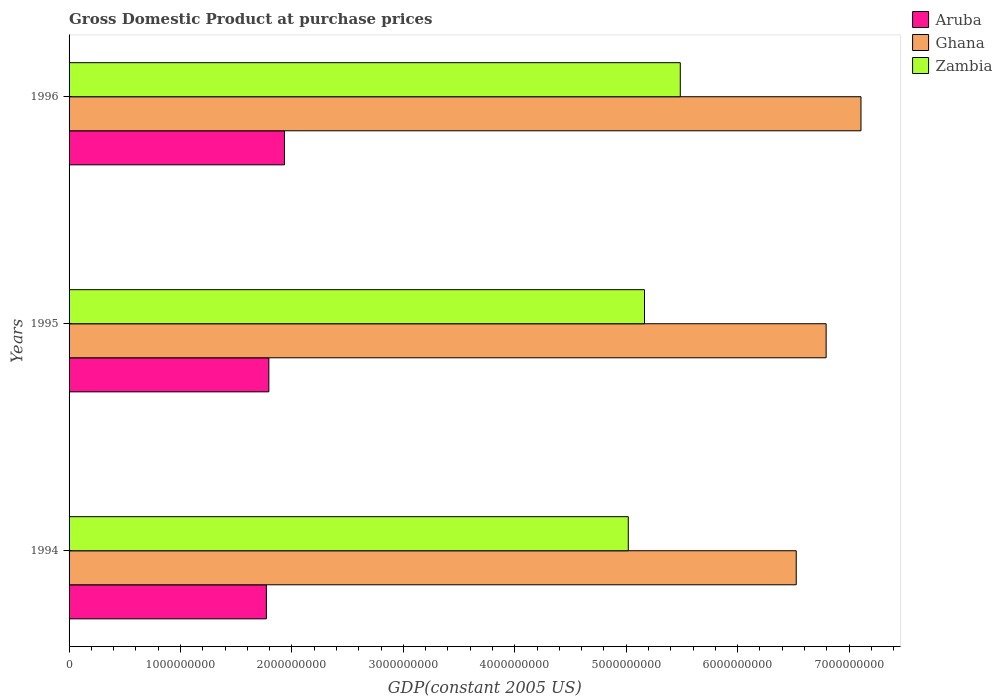How many different coloured bars are there?
Ensure brevity in your answer.  3. How many groups of bars are there?
Offer a terse response. 3. Are the number of bars per tick equal to the number of legend labels?
Your answer should be very brief. Yes. How many bars are there on the 2nd tick from the bottom?
Provide a short and direct response. 3. What is the label of the 3rd group of bars from the top?
Your response must be concise. 1994. In how many cases, is the number of bars for a given year not equal to the number of legend labels?
Your answer should be compact. 0. What is the GDP at purchase prices in Ghana in 1994?
Your response must be concise. 6.53e+09. Across all years, what is the maximum GDP at purchase prices in Ghana?
Offer a very short reply. 7.11e+09. Across all years, what is the minimum GDP at purchase prices in Zambia?
Offer a terse response. 5.02e+09. In which year was the GDP at purchase prices in Ghana minimum?
Your answer should be compact. 1994. What is the total GDP at purchase prices in Aruba in the graph?
Your answer should be very brief. 5.50e+09. What is the difference between the GDP at purchase prices in Aruba in 1994 and that in 1995?
Your answer should be very brief. -2.20e+07. What is the difference between the GDP at purchase prices in Aruba in 1994 and the GDP at purchase prices in Ghana in 1996?
Make the answer very short. -5.34e+09. What is the average GDP at purchase prices in Zambia per year?
Your answer should be very brief. 5.22e+09. In the year 1995, what is the difference between the GDP at purchase prices in Aruba and GDP at purchase prices in Ghana?
Your answer should be very brief. -5.00e+09. What is the ratio of the GDP at purchase prices in Aruba in 1994 to that in 1996?
Provide a succinct answer. 0.92. Is the GDP at purchase prices in Aruba in 1994 less than that in 1995?
Offer a very short reply. Yes. Is the difference between the GDP at purchase prices in Aruba in 1994 and 1995 greater than the difference between the GDP at purchase prices in Ghana in 1994 and 1995?
Your answer should be very brief. Yes. What is the difference between the highest and the second highest GDP at purchase prices in Zambia?
Provide a succinct answer. 3.21e+08. What is the difference between the highest and the lowest GDP at purchase prices in Zambia?
Your answer should be compact. 4.67e+08. In how many years, is the GDP at purchase prices in Aruba greater than the average GDP at purchase prices in Aruba taken over all years?
Your answer should be compact. 1. What does the 1st bar from the top in 1996 represents?
Make the answer very short. Zambia. What does the 3rd bar from the bottom in 1994 represents?
Offer a very short reply. Zambia. Is it the case that in every year, the sum of the GDP at purchase prices in Zambia and GDP at purchase prices in Ghana is greater than the GDP at purchase prices in Aruba?
Your answer should be compact. Yes. Where does the legend appear in the graph?
Provide a succinct answer. Top right. How many legend labels are there?
Ensure brevity in your answer.  3. What is the title of the graph?
Give a very brief answer. Gross Domestic Product at purchase prices. Does "Kyrgyz Republic" appear as one of the legend labels in the graph?
Provide a succinct answer. No. What is the label or title of the X-axis?
Ensure brevity in your answer.  GDP(constant 2005 US). What is the GDP(constant 2005 US) in Aruba in 1994?
Ensure brevity in your answer.  1.77e+09. What is the GDP(constant 2005 US) in Ghana in 1994?
Provide a succinct answer. 6.53e+09. What is the GDP(constant 2005 US) in Zambia in 1994?
Provide a short and direct response. 5.02e+09. What is the GDP(constant 2005 US) in Aruba in 1995?
Your answer should be very brief. 1.79e+09. What is the GDP(constant 2005 US) of Ghana in 1995?
Make the answer very short. 6.79e+09. What is the GDP(constant 2005 US) of Zambia in 1995?
Offer a very short reply. 5.16e+09. What is the GDP(constant 2005 US) of Aruba in 1996?
Ensure brevity in your answer.  1.93e+09. What is the GDP(constant 2005 US) of Ghana in 1996?
Your response must be concise. 7.11e+09. What is the GDP(constant 2005 US) of Zambia in 1996?
Give a very brief answer. 5.48e+09. Across all years, what is the maximum GDP(constant 2005 US) in Aruba?
Give a very brief answer. 1.93e+09. Across all years, what is the maximum GDP(constant 2005 US) in Ghana?
Make the answer very short. 7.11e+09. Across all years, what is the maximum GDP(constant 2005 US) in Zambia?
Provide a succinct answer. 5.48e+09. Across all years, what is the minimum GDP(constant 2005 US) of Aruba?
Make the answer very short. 1.77e+09. Across all years, what is the minimum GDP(constant 2005 US) in Ghana?
Offer a very short reply. 6.53e+09. Across all years, what is the minimum GDP(constant 2005 US) of Zambia?
Offer a very short reply. 5.02e+09. What is the total GDP(constant 2005 US) in Aruba in the graph?
Provide a succinct answer. 5.50e+09. What is the total GDP(constant 2005 US) of Ghana in the graph?
Provide a short and direct response. 2.04e+1. What is the total GDP(constant 2005 US) in Zambia in the graph?
Provide a succinct answer. 1.57e+1. What is the difference between the GDP(constant 2005 US) of Aruba in 1994 and that in 1995?
Provide a succinct answer. -2.20e+07. What is the difference between the GDP(constant 2005 US) of Ghana in 1994 and that in 1995?
Offer a very short reply. -2.68e+08. What is the difference between the GDP(constant 2005 US) in Zambia in 1994 and that in 1995?
Your answer should be compact. -1.45e+08. What is the difference between the GDP(constant 2005 US) of Aruba in 1994 and that in 1996?
Your answer should be compact. -1.62e+08. What is the difference between the GDP(constant 2005 US) in Ghana in 1994 and that in 1996?
Your response must be concise. -5.81e+08. What is the difference between the GDP(constant 2005 US) in Zambia in 1994 and that in 1996?
Offer a very short reply. -4.67e+08. What is the difference between the GDP(constant 2005 US) in Aruba in 1995 and that in 1996?
Give a very brief answer. -1.40e+08. What is the difference between the GDP(constant 2005 US) in Ghana in 1995 and that in 1996?
Your response must be concise. -3.13e+08. What is the difference between the GDP(constant 2005 US) in Zambia in 1995 and that in 1996?
Ensure brevity in your answer.  -3.21e+08. What is the difference between the GDP(constant 2005 US) of Aruba in 1994 and the GDP(constant 2005 US) of Ghana in 1995?
Provide a succinct answer. -5.02e+09. What is the difference between the GDP(constant 2005 US) of Aruba in 1994 and the GDP(constant 2005 US) of Zambia in 1995?
Offer a terse response. -3.39e+09. What is the difference between the GDP(constant 2005 US) in Ghana in 1994 and the GDP(constant 2005 US) in Zambia in 1995?
Offer a terse response. 1.36e+09. What is the difference between the GDP(constant 2005 US) of Aruba in 1994 and the GDP(constant 2005 US) of Ghana in 1996?
Your answer should be very brief. -5.34e+09. What is the difference between the GDP(constant 2005 US) of Aruba in 1994 and the GDP(constant 2005 US) of Zambia in 1996?
Offer a terse response. -3.71e+09. What is the difference between the GDP(constant 2005 US) in Ghana in 1994 and the GDP(constant 2005 US) in Zambia in 1996?
Your response must be concise. 1.04e+09. What is the difference between the GDP(constant 2005 US) in Aruba in 1995 and the GDP(constant 2005 US) in Ghana in 1996?
Your answer should be compact. -5.31e+09. What is the difference between the GDP(constant 2005 US) of Aruba in 1995 and the GDP(constant 2005 US) of Zambia in 1996?
Ensure brevity in your answer.  -3.69e+09. What is the difference between the GDP(constant 2005 US) of Ghana in 1995 and the GDP(constant 2005 US) of Zambia in 1996?
Offer a terse response. 1.31e+09. What is the average GDP(constant 2005 US) in Aruba per year?
Offer a very short reply. 1.83e+09. What is the average GDP(constant 2005 US) of Ghana per year?
Offer a terse response. 6.81e+09. What is the average GDP(constant 2005 US) in Zambia per year?
Keep it short and to the point. 5.22e+09. In the year 1994, what is the difference between the GDP(constant 2005 US) in Aruba and GDP(constant 2005 US) in Ghana?
Your answer should be compact. -4.75e+09. In the year 1994, what is the difference between the GDP(constant 2005 US) of Aruba and GDP(constant 2005 US) of Zambia?
Your response must be concise. -3.25e+09. In the year 1994, what is the difference between the GDP(constant 2005 US) in Ghana and GDP(constant 2005 US) in Zambia?
Offer a terse response. 1.51e+09. In the year 1995, what is the difference between the GDP(constant 2005 US) in Aruba and GDP(constant 2005 US) in Ghana?
Offer a very short reply. -5.00e+09. In the year 1995, what is the difference between the GDP(constant 2005 US) of Aruba and GDP(constant 2005 US) of Zambia?
Provide a short and direct response. -3.37e+09. In the year 1995, what is the difference between the GDP(constant 2005 US) in Ghana and GDP(constant 2005 US) in Zambia?
Offer a very short reply. 1.63e+09. In the year 1996, what is the difference between the GDP(constant 2005 US) in Aruba and GDP(constant 2005 US) in Ghana?
Ensure brevity in your answer.  -5.17e+09. In the year 1996, what is the difference between the GDP(constant 2005 US) of Aruba and GDP(constant 2005 US) of Zambia?
Offer a very short reply. -3.55e+09. In the year 1996, what is the difference between the GDP(constant 2005 US) of Ghana and GDP(constant 2005 US) of Zambia?
Ensure brevity in your answer.  1.62e+09. What is the ratio of the GDP(constant 2005 US) in Aruba in 1994 to that in 1995?
Offer a terse response. 0.99. What is the ratio of the GDP(constant 2005 US) of Ghana in 1994 to that in 1995?
Give a very brief answer. 0.96. What is the ratio of the GDP(constant 2005 US) in Zambia in 1994 to that in 1995?
Provide a succinct answer. 0.97. What is the ratio of the GDP(constant 2005 US) of Aruba in 1994 to that in 1996?
Your answer should be very brief. 0.92. What is the ratio of the GDP(constant 2005 US) of Ghana in 1994 to that in 1996?
Give a very brief answer. 0.92. What is the ratio of the GDP(constant 2005 US) in Zambia in 1994 to that in 1996?
Offer a terse response. 0.91. What is the ratio of the GDP(constant 2005 US) of Aruba in 1995 to that in 1996?
Provide a short and direct response. 0.93. What is the ratio of the GDP(constant 2005 US) in Ghana in 1995 to that in 1996?
Give a very brief answer. 0.96. What is the ratio of the GDP(constant 2005 US) of Zambia in 1995 to that in 1996?
Provide a succinct answer. 0.94. What is the difference between the highest and the second highest GDP(constant 2005 US) in Aruba?
Make the answer very short. 1.40e+08. What is the difference between the highest and the second highest GDP(constant 2005 US) of Ghana?
Your answer should be compact. 3.13e+08. What is the difference between the highest and the second highest GDP(constant 2005 US) in Zambia?
Your response must be concise. 3.21e+08. What is the difference between the highest and the lowest GDP(constant 2005 US) in Aruba?
Provide a succinct answer. 1.62e+08. What is the difference between the highest and the lowest GDP(constant 2005 US) in Ghana?
Keep it short and to the point. 5.81e+08. What is the difference between the highest and the lowest GDP(constant 2005 US) of Zambia?
Keep it short and to the point. 4.67e+08. 